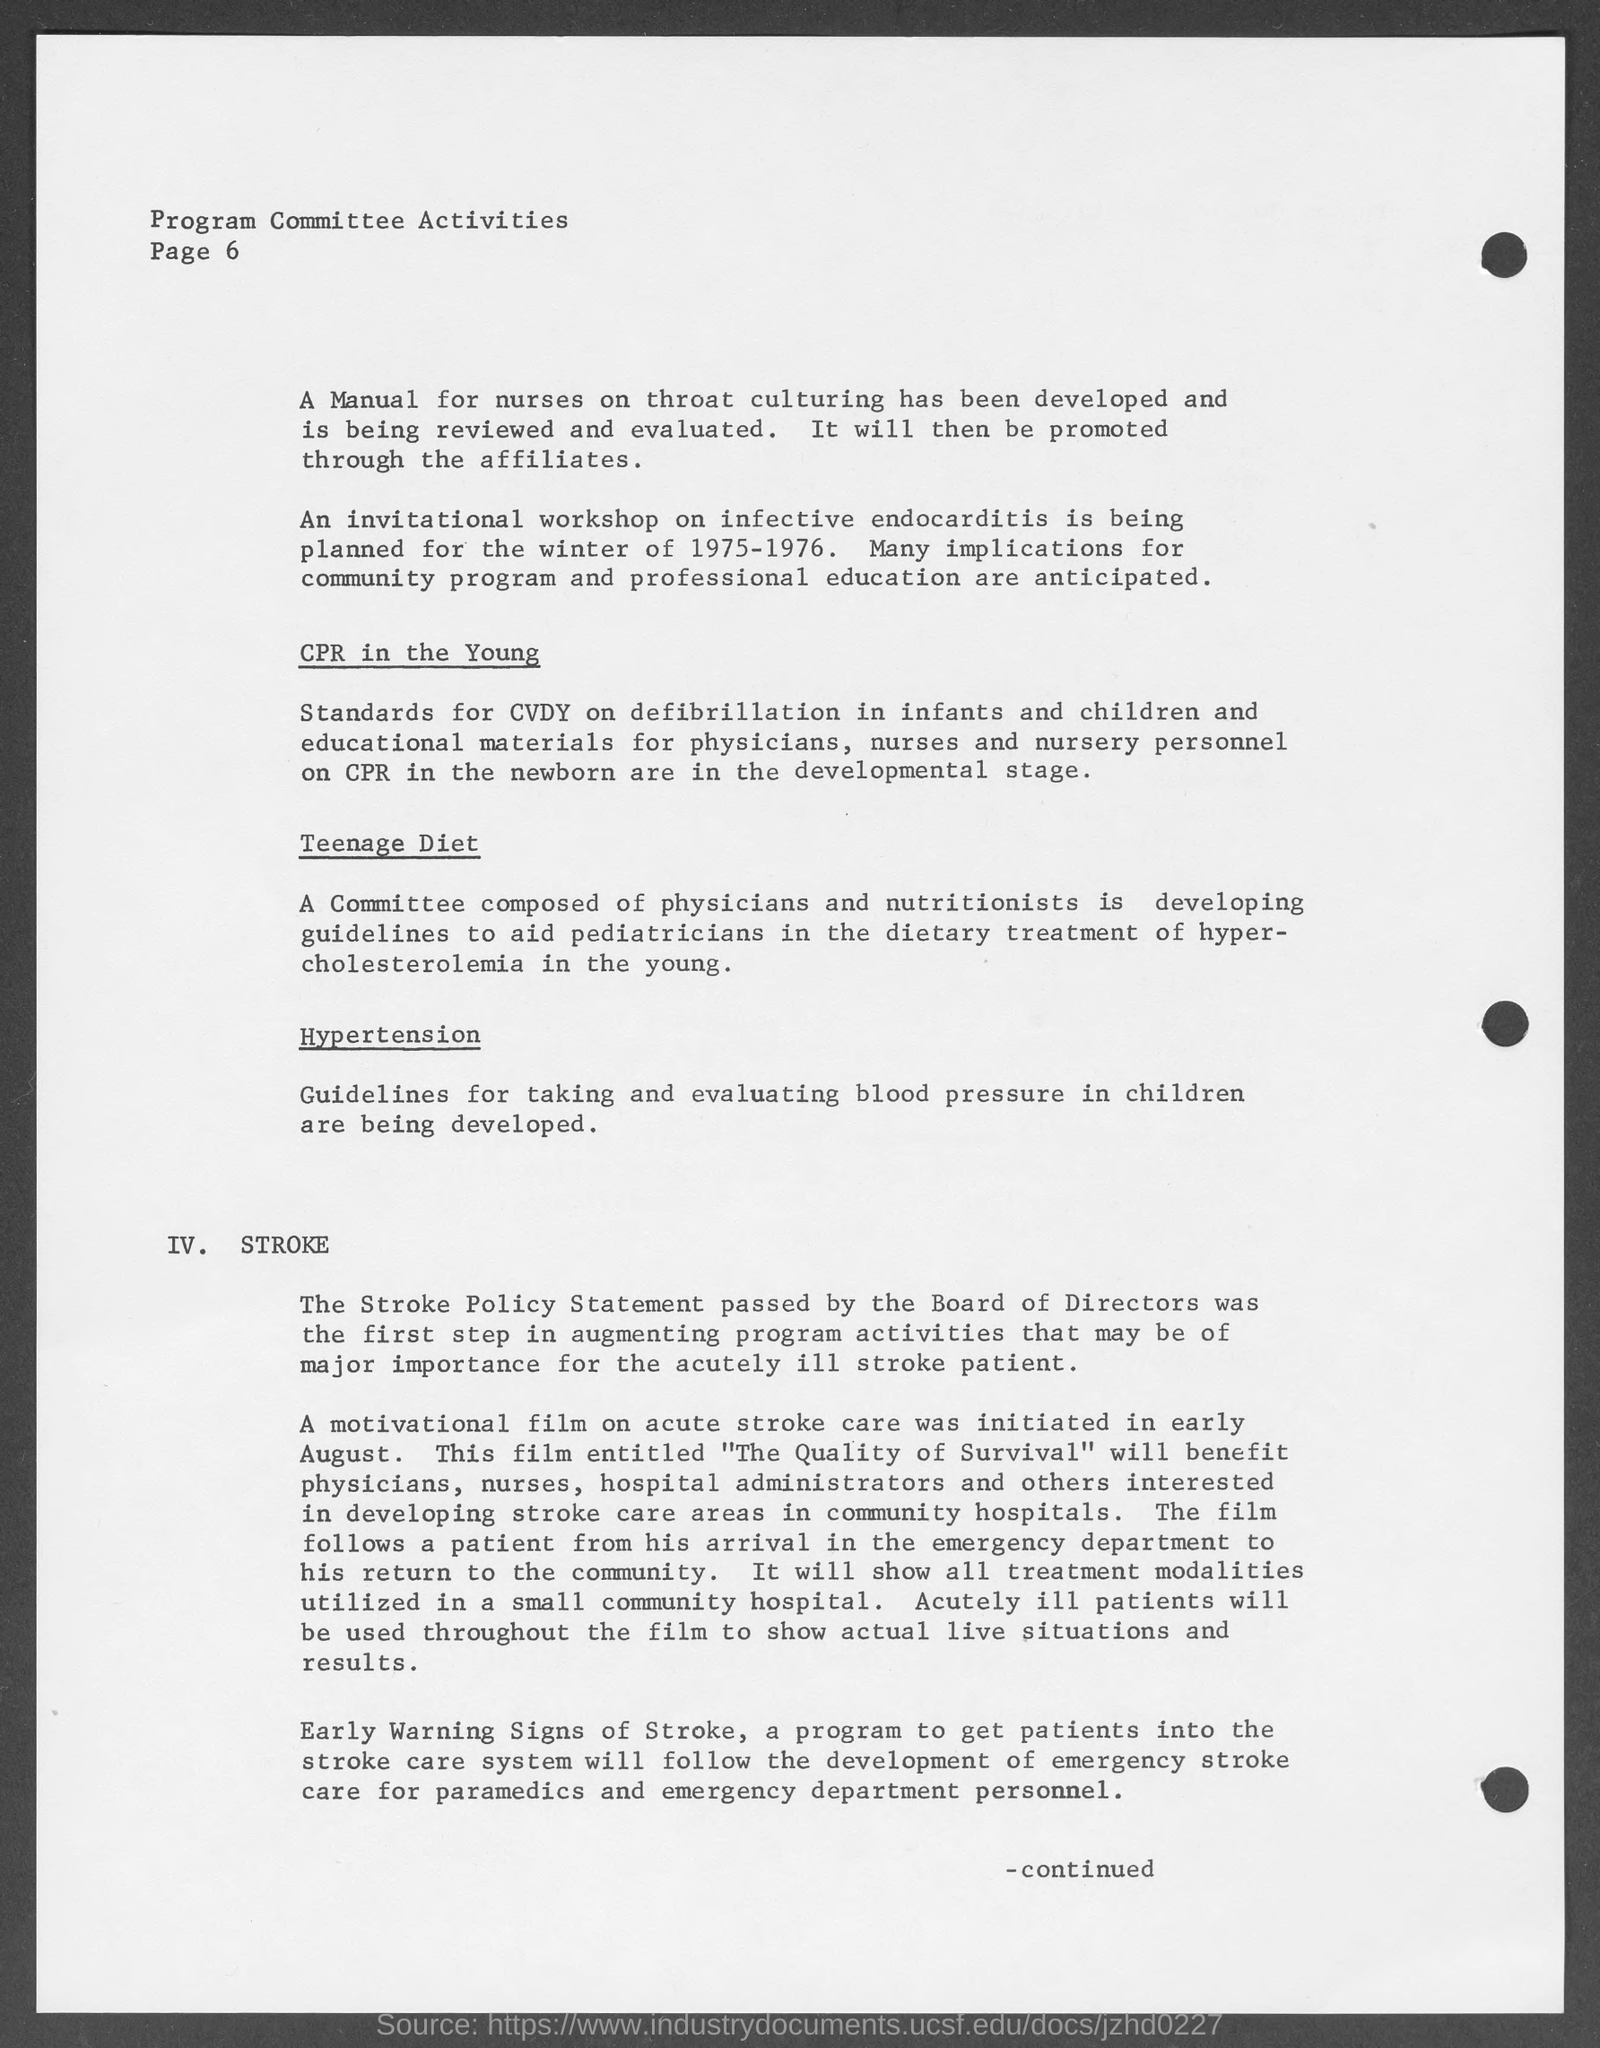Indicate a few pertinent items in this graphic. The program committee activities are written on the top left corner of the page. It is announced that an invitational workshop on infective endocarditis will be held in the years 1975-1976. The page number mentioned in the document is 6. 